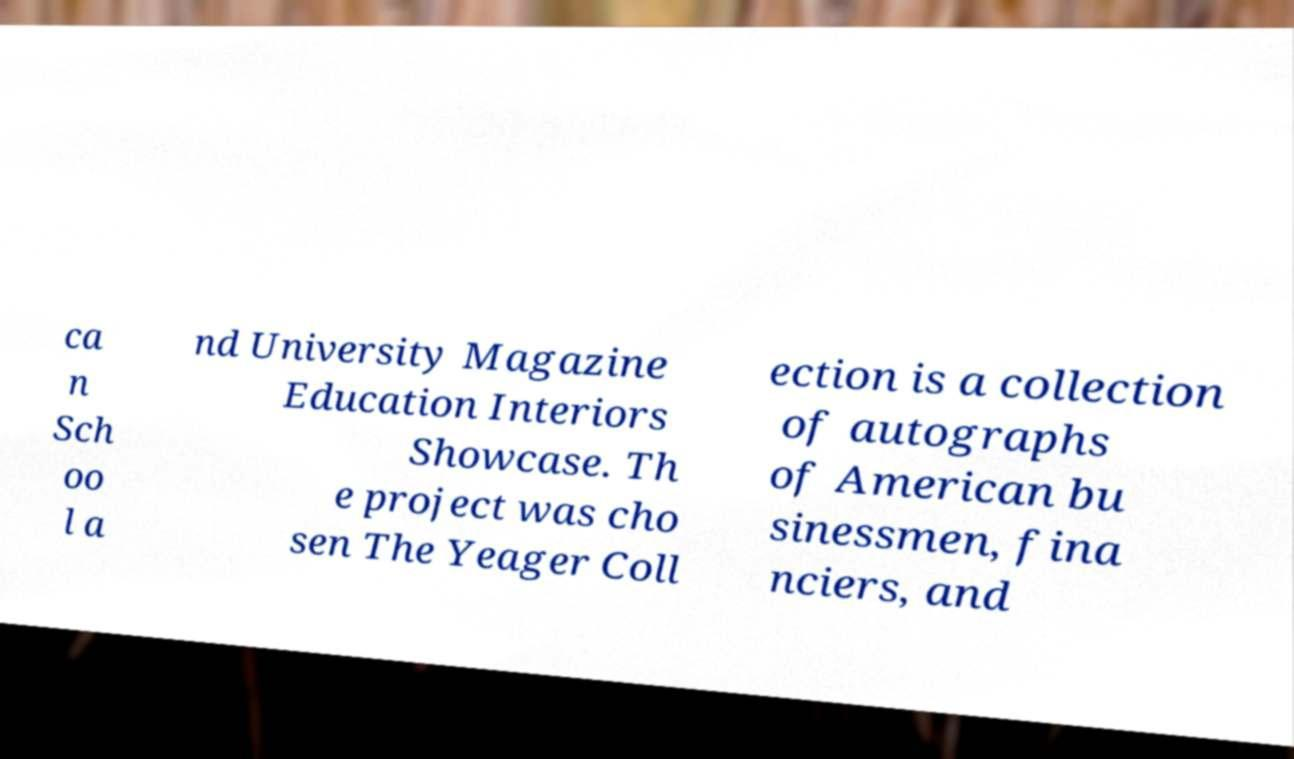Please identify and transcribe the text found in this image. ca n Sch oo l a nd University Magazine Education Interiors Showcase. Th e project was cho sen The Yeager Coll ection is a collection of autographs of American bu sinessmen, fina nciers, and 